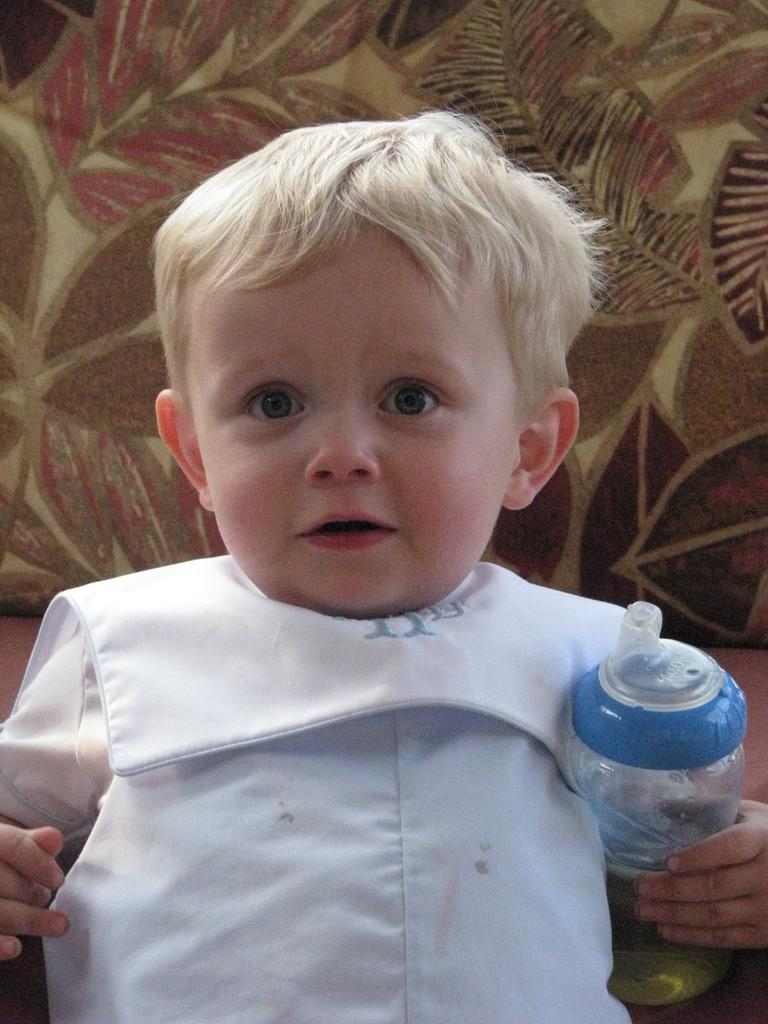Who is the main subject in the image? There is a boy in the image. What is the boy doing in the image? The boy is standing at a sofa. What is the boy holding in his hand? The boy is holding a bottle in his hand. What grade does the boy need to pass in order to get the rock in the image? There is no rock present in the image, and therefore no grade requirement or reward associated with it. 